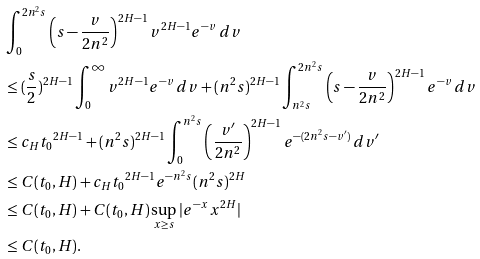Convert formula to latex. <formula><loc_0><loc_0><loc_500><loc_500>& \int _ { 0 } ^ { 2 n ^ { 2 } s } \left ( s - \frac { v } { 2 n ^ { 2 } } \right ) ^ { 2 H - 1 } v ^ { 2 H - 1 } e ^ { - v } \, d v \\ & \leq ( \frac { s } { 2 } ) ^ { 2 H - 1 } \int _ { 0 } ^ { \infty } v ^ { 2 H - 1 } e ^ { - v } \, d v + ( n ^ { 2 } s ) ^ { 2 H - 1 } \int _ { n ^ { 2 } s } ^ { 2 n ^ { 2 } s } \left ( s - \frac { v } { 2 n ^ { 2 } } \right ) ^ { 2 H - 1 } e ^ { - v } \, d v \\ & \leq c _ { H } { t _ { 0 } } ^ { 2 H - 1 } + ( n ^ { 2 } s ) ^ { 2 H - 1 } \int _ { 0 } ^ { n ^ { 2 } s } \left ( \frac { v ^ { \prime } } { 2 n ^ { 2 } } \right ) ^ { 2 H - 1 } e ^ { - ( 2 n ^ { 2 } s - v ^ { \prime } ) } \, d v ^ { \prime } \\ & \leq C ( t _ { 0 } , H ) + c _ { H } { t _ { 0 } } ^ { 2 H - 1 } e ^ { - n ^ { 2 } s } ( n ^ { 2 } s ) ^ { 2 H } \\ & \leq C ( t _ { 0 } , H ) + C ( t _ { 0 } , H ) \sup _ { x \geq s } | e ^ { - x } x ^ { 2 H } | \\ & \leq C ( t _ { 0 } , H ) .</formula> 